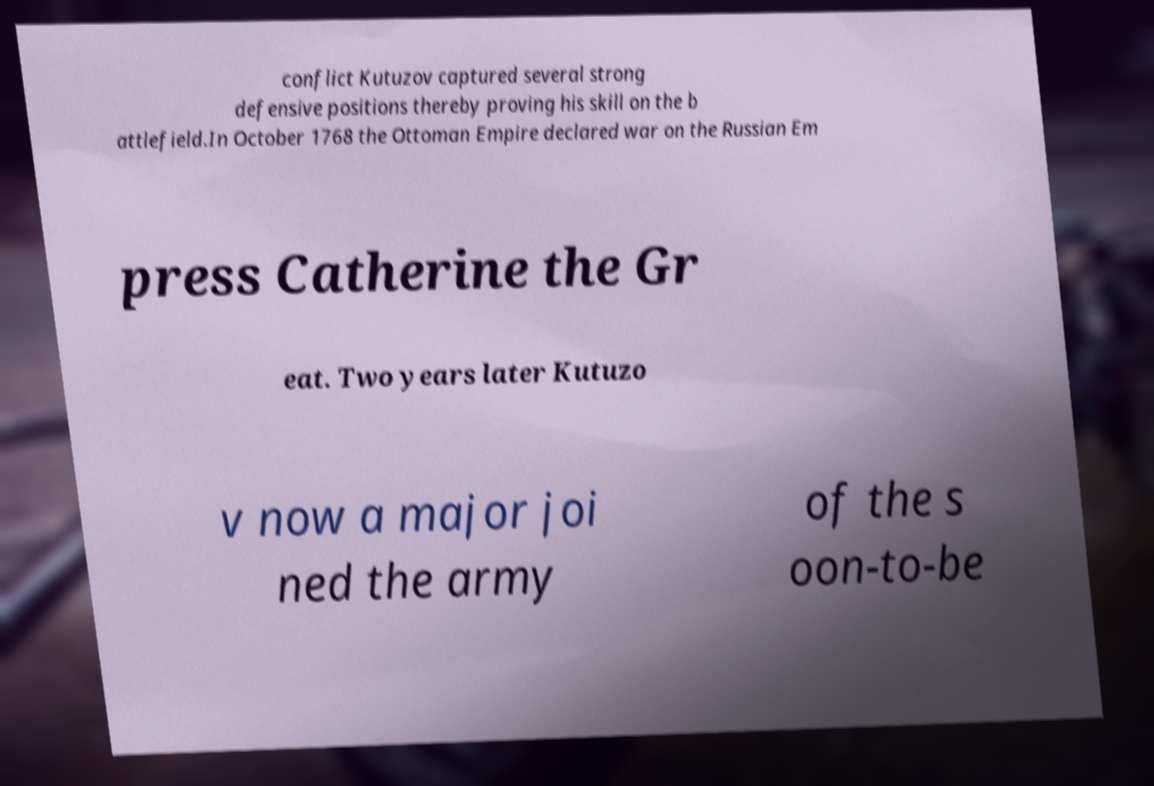I need the written content from this picture converted into text. Can you do that? conflict Kutuzov captured several strong defensive positions thereby proving his skill on the b attlefield.In October 1768 the Ottoman Empire declared war on the Russian Em press Catherine the Gr eat. Two years later Kutuzo v now a major joi ned the army of the s oon-to-be 